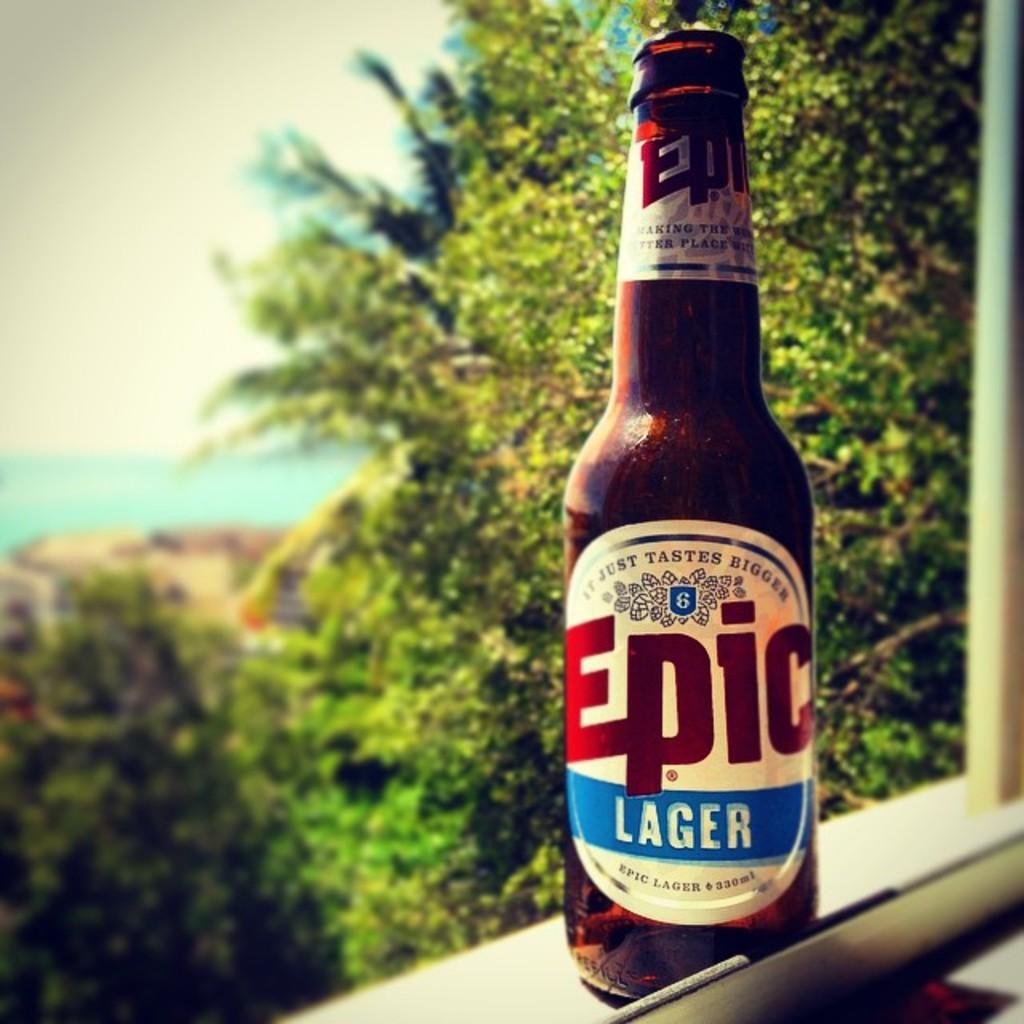What kind if beer is this?
Your response must be concise. Epic lager. What is the name of this lager?
Ensure brevity in your answer.  Epic. 